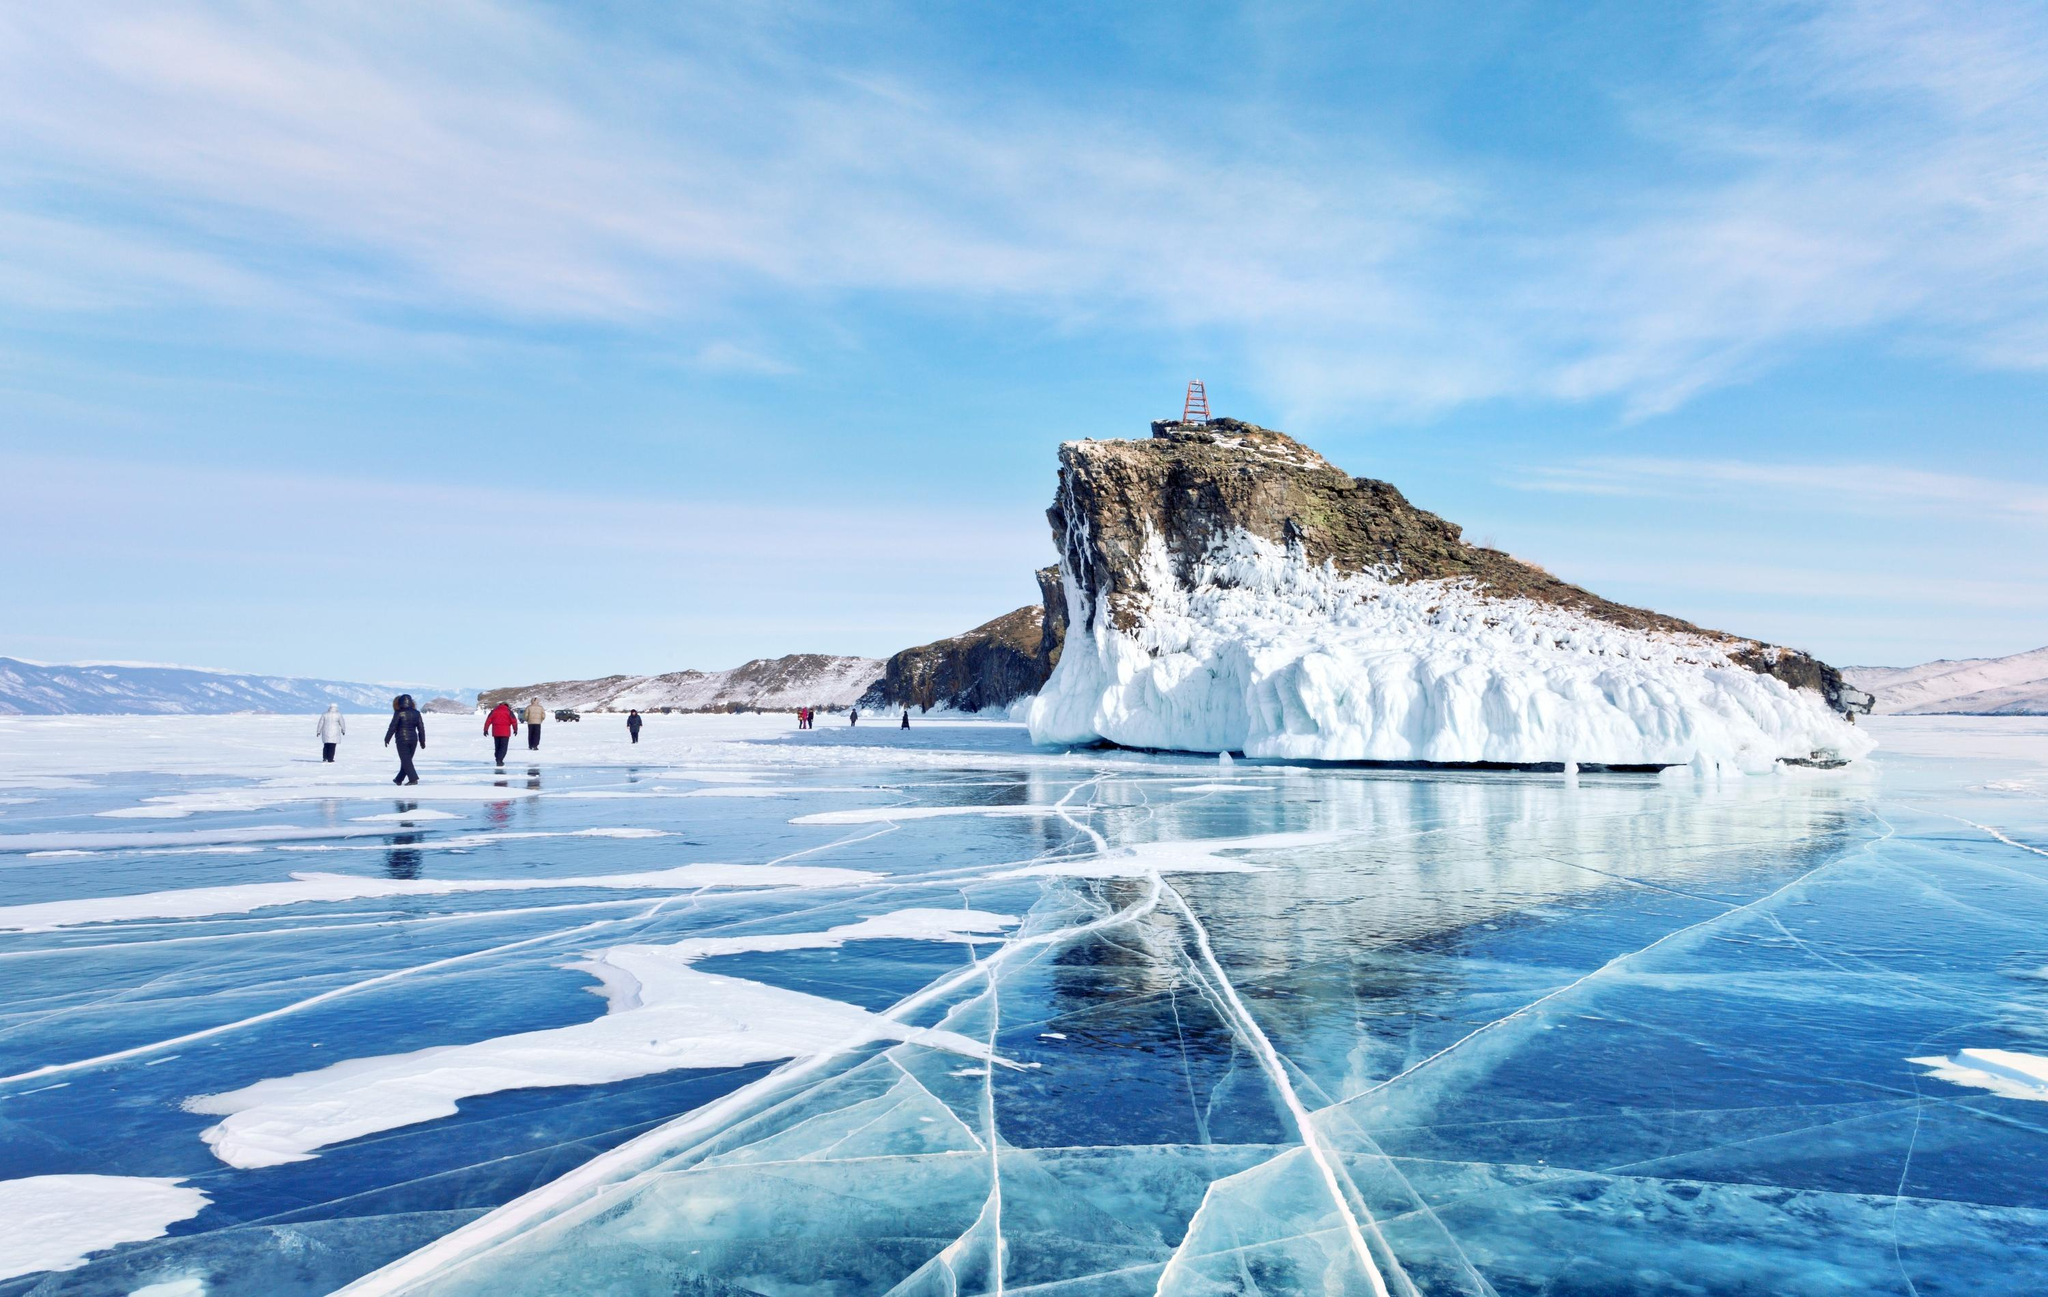Can you tell me about the ecosystem and wildlife that thrives in and around Lake Baikal in the winter? During the cold winters, Lake Baikal hosts a unique ecosystem. It is home to the Baikal seal, or nerpa, the only freshwater seal in the world, which can often be seen sunbathing on the ice. Beneath the ice, aquatic life continues with endemic species such as the Baikal oilfish. The surrounding terrain supports Siberian roe deer, brown bears, and wolves, although these are less active in winter. Birds like the Baikal teal and the whooper swan visit seasonally. The lake's remarkable clarity and oxygen-rich waters make it a critical habitat, supporting biodiversity that is mostly unique to this region. 